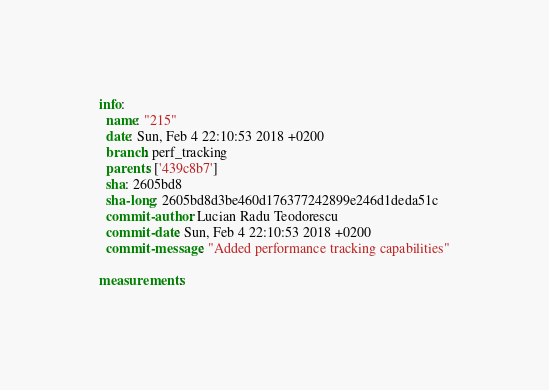<code> <loc_0><loc_0><loc_500><loc_500><_YAML_>info:
  name: "215"
  date: Sun, Feb 4 22:10:53 2018 +0200
  branch: perf_tracking
  parents: ['439c8b7']
  sha: 2605bd8
  sha-long: 2605bd8d3be460d176377242899e246d1deda51c
  commit-author: Lucian Radu Teodorescu
  commit-date: Sun, Feb 4 22:10:53 2018 +0200
  commit-message: "Added performance tracking capabilities"

measurements:</code> 